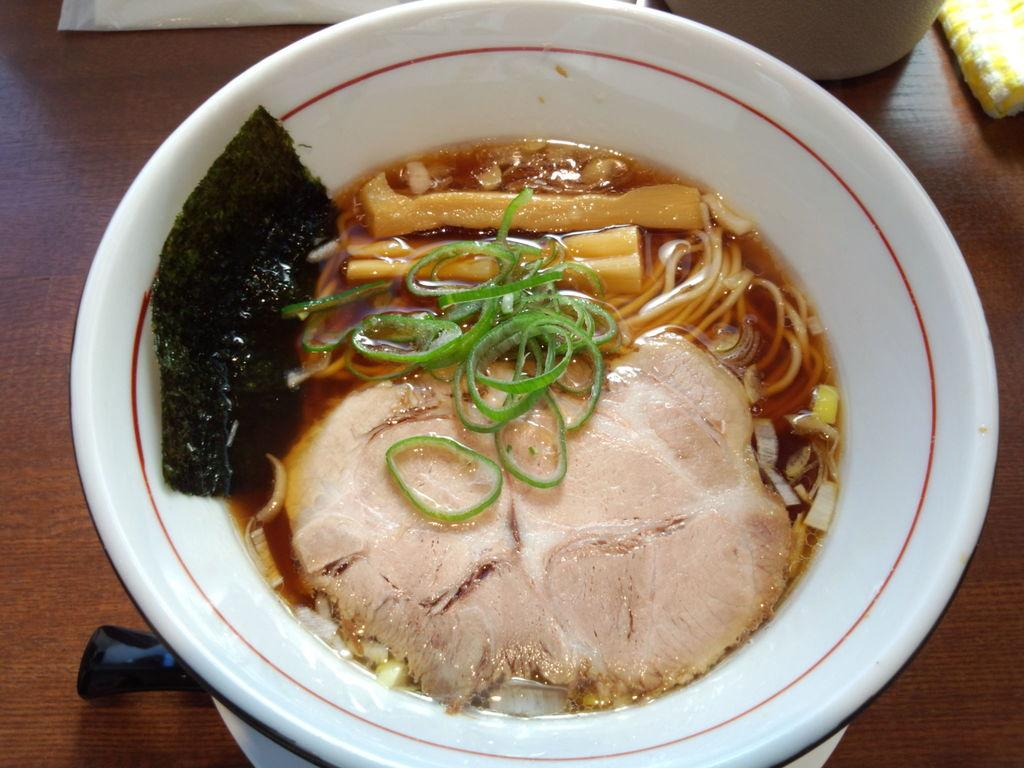What color is the bowl in the image? The bowl in the image is white. What is inside the bowl? The bowl contains soup. On what surface is the bowl placed? The bowl is on a wooden surface. What can be seen at the top of the image? There are objects visible at the top of the image. Who is the owner of the soup in the image? There is no information about the owner of the soup in the image. Is there a locket hanging from the bowl in the image? There is no locket visible in the image. 